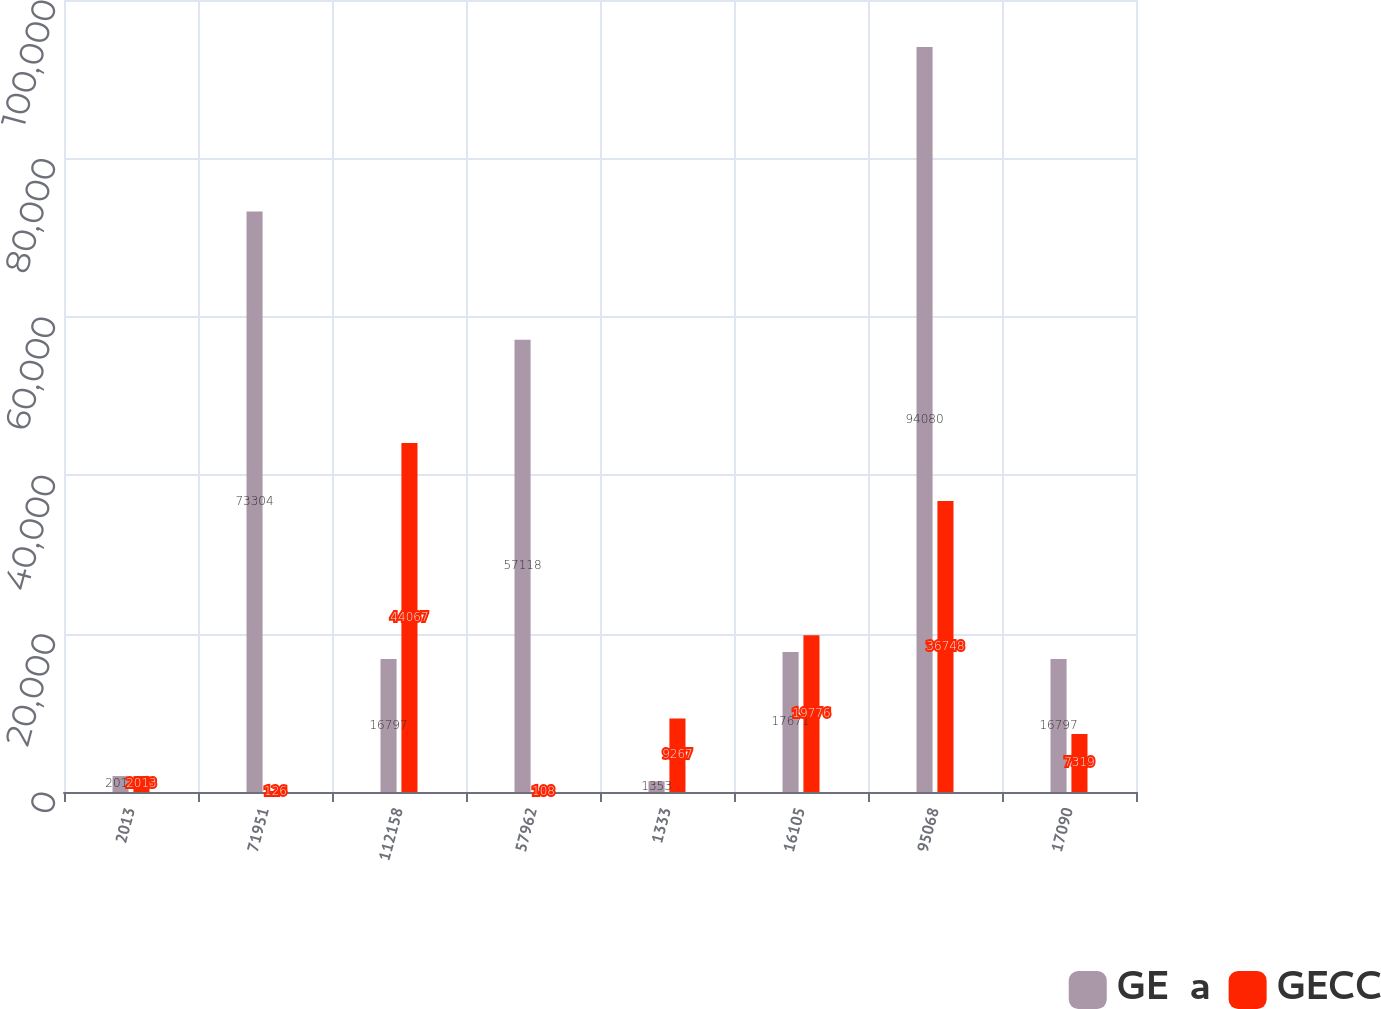Convert chart. <chart><loc_0><loc_0><loc_500><loc_500><stacked_bar_chart><ecel><fcel>2013<fcel>71951<fcel>112158<fcel>57962<fcel>1333<fcel>16105<fcel>95068<fcel>17090<nl><fcel>GE  a<fcel>2012<fcel>73304<fcel>16797<fcel>57118<fcel>1353<fcel>17671<fcel>94080<fcel>16797<nl><fcel>GECC<fcel>2013<fcel>126<fcel>44067<fcel>108<fcel>9267<fcel>19776<fcel>36748<fcel>7319<nl></chart> 